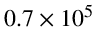Convert formula to latex. <formula><loc_0><loc_0><loc_500><loc_500>0 . 7 \times 1 0 ^ { 5 }</formula> 